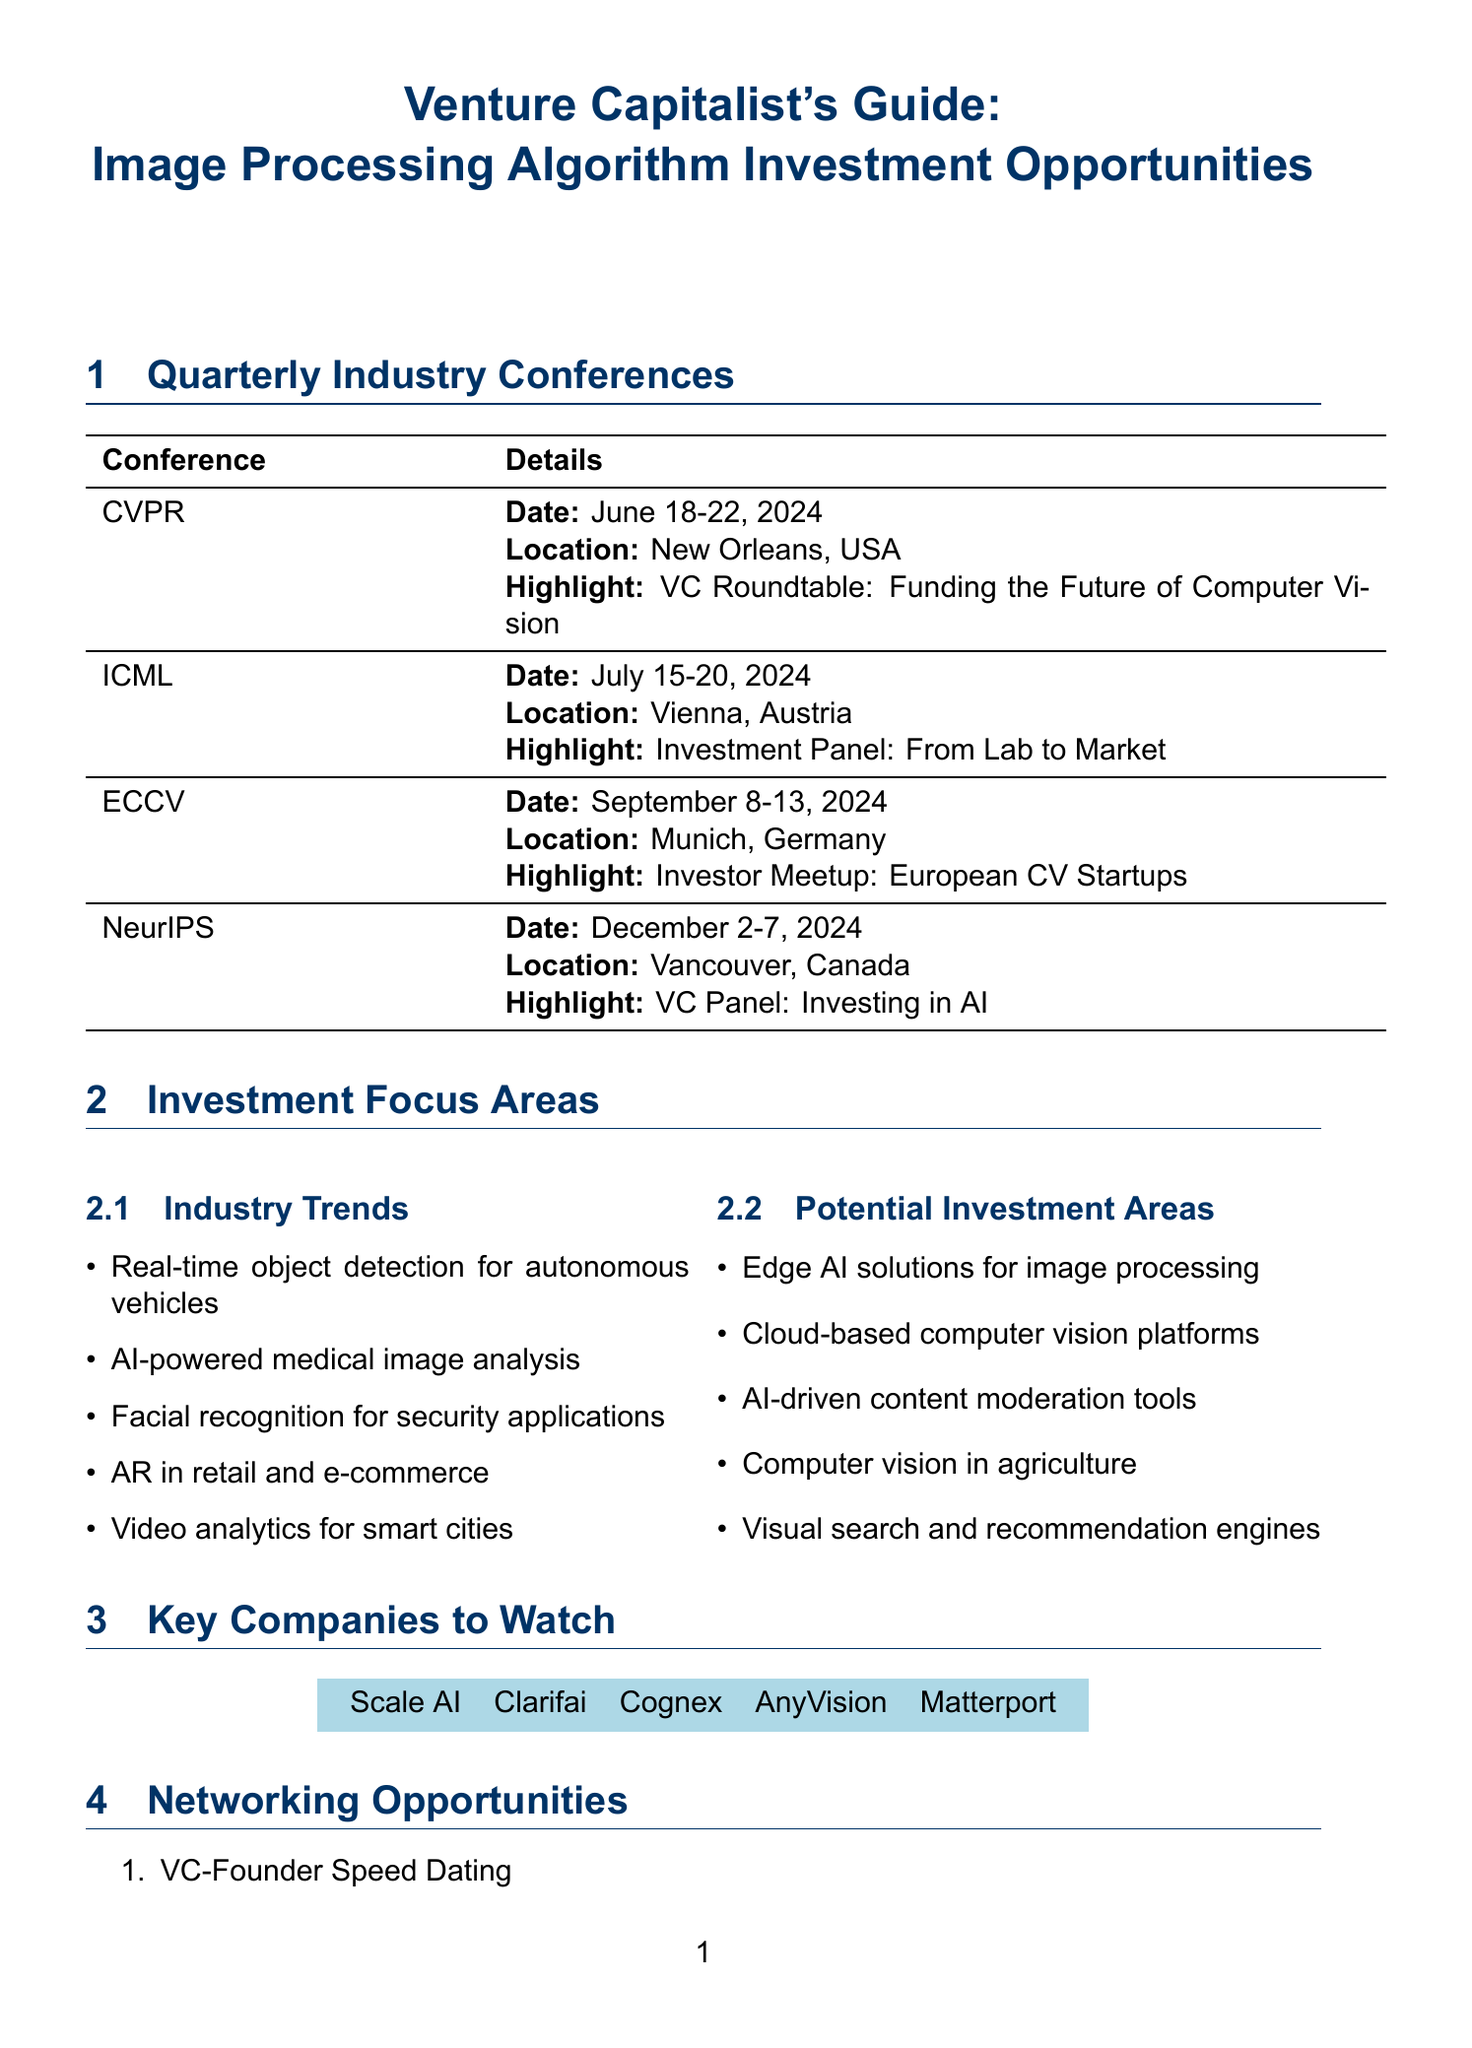what is the date of CVPR? The date of the CVPR conference is given in the document as June 18-22, 2024.
Answer: June 18-22, 2024 who are the keynote speakers for ICML? The document lists the keynote speakers for ICML as Geoffrey Hinton and Yoshua Bengio.
Answer: Geoffrey Hinton, Yoshua Bengio what is one of the topics discussed at NeurIPS? The document mentions several topics at NeurIPS, one of which is "Computer vision applications."
Answer: Computer vision applications which company is listed as a key company to watch? The document contains a list of companies, one of which is Scale AI.
Answer: Scale AI what is the location of ECCV? The location of the ECCV conference is specified in the document as Munich, Germany.
Answer: Munich, Germany what is the startup pitch session at CVPR about? The document describes the startup pitch session at CVPR as focusing on "AI in Healthcare: Emerging Opportunities."
Answer: AI in Healthcare: Emerging Opportunities how many networking opportunities are listed? The document enumerates five networking opportunities available at the conferences.
Answer: 5 which conference has a workshop on Edge AI? According to the document, the ICML conference includes a workshop specifically titled "Edge AI: Processing Images on Mobile Devices."
Answer: ICML what is the potential investment area related to cloud solutions? The document highlights "Cloud-based computer vision platforms" as a potential investment area.
Answer: Cloud-based computer vision platforms 